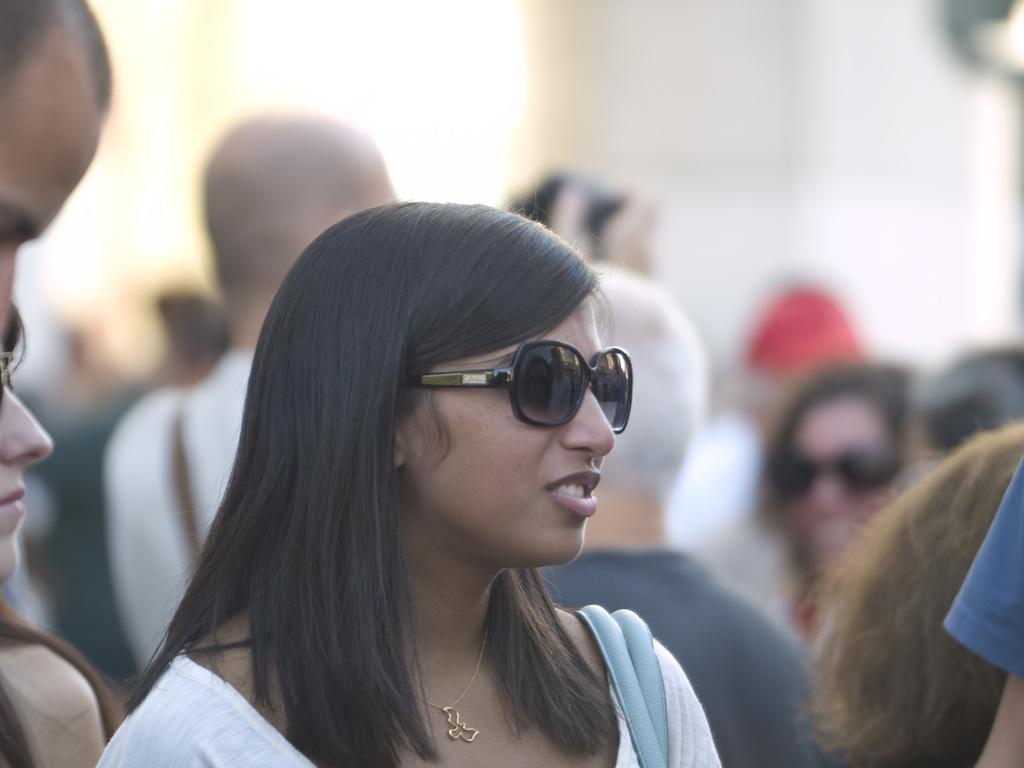Describe this image in one or two sentences. In this image, I can see the woman standing with the goggles and there are few people standing. The background looks blurry. 